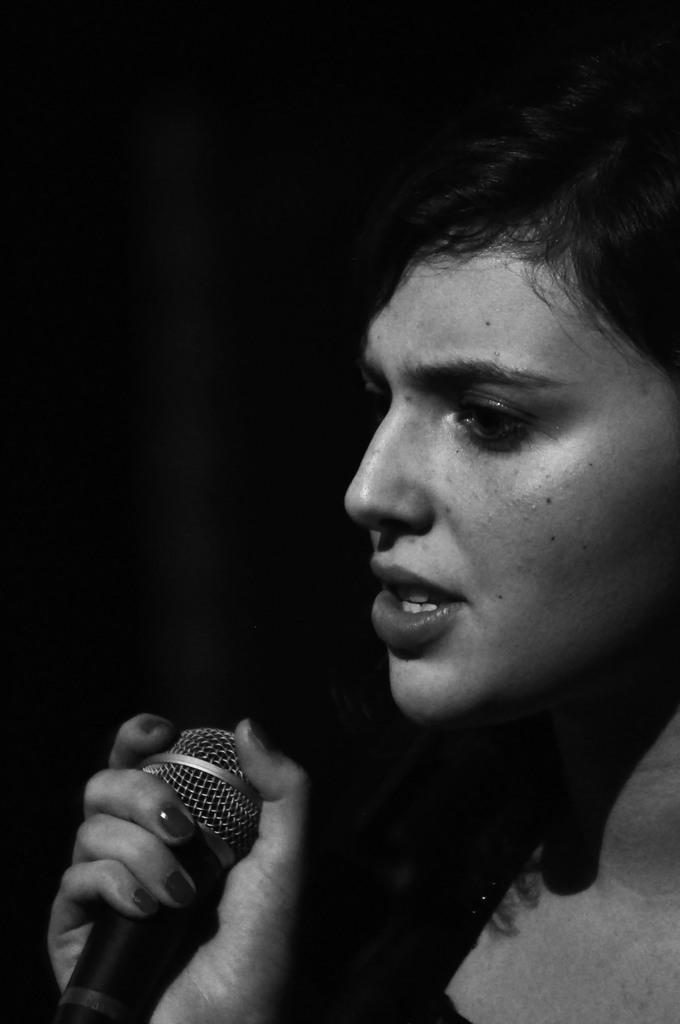In one or two sentences, can you explain what this image depicts? In this picture there is a lady on the right side of the image, by holding a mic in her hand. 